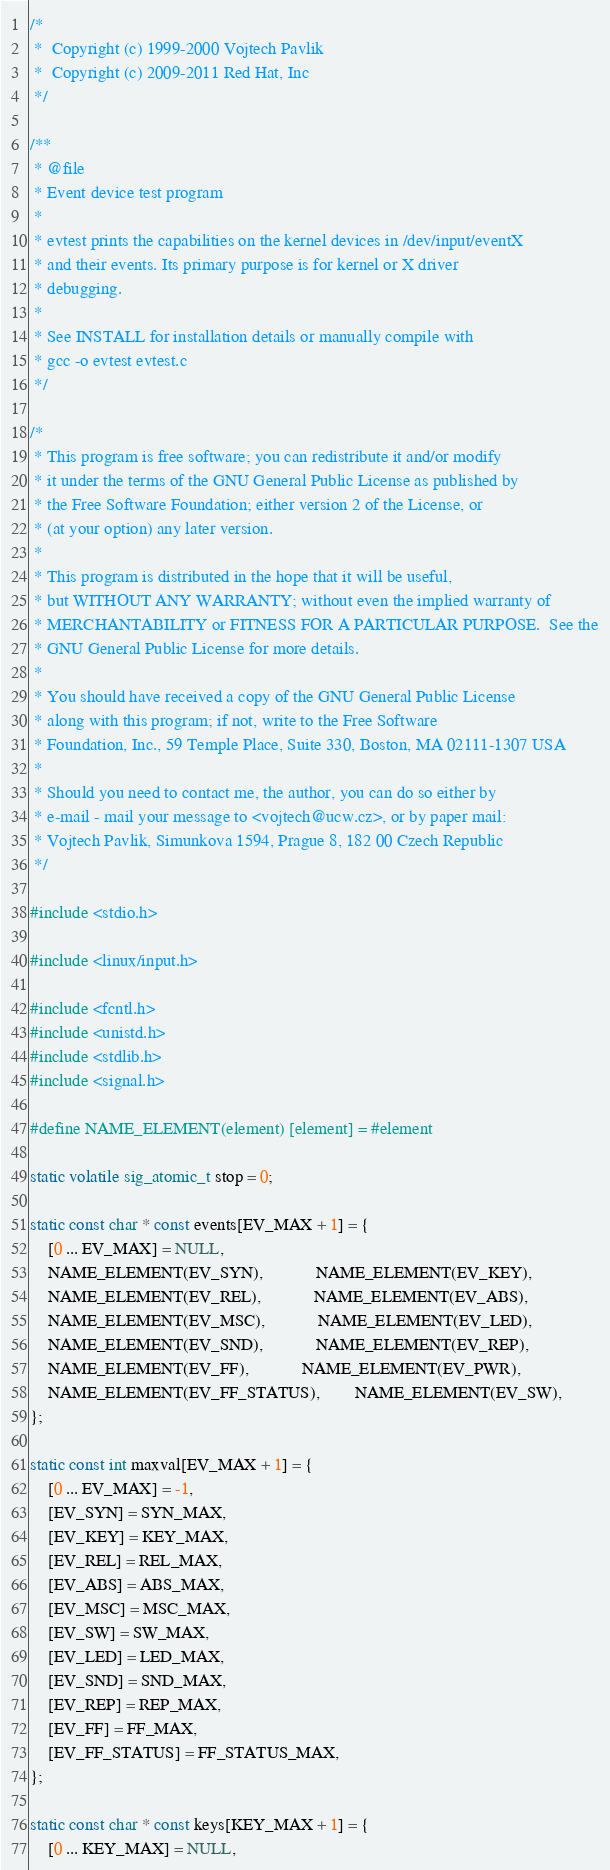<code> <loc_0><loc_0><loc_500><loc_500><_C_>/*
 *  Copyright (c) 1999-2000 Vojtech Pavlik
 *  Copyright (c) 2009-2011 Red Hat, Inc
 */

/**
 * @file
 * Event device test program
 *
 * evtest prints the capabilities on the kernel devices in /dev/input/eventX
 * and their events. Its primary purpose is for kernel or X driver
 * debugging.
 *
 * See INSTALL for installation details or manually compile with
 * gcc -o evtest evtest.c
 */

/*
 * This program is free software; you can redistribute it and/or modify
 * it under the terms of the GNU General Public License as published by
 * the Free Software Foundation; either version 2 of the License, or
 * (at your option) any later version.
 *
 * This program is distributed in the hope that it will be useful,
 * but WITHOUT ANY WARRANTY; without even the implied warranty of
 * MERCHANTABILITY or FITNESS FOR A PARTICULAR PURPOSE.  See the
 * GNU General Public License for more details.
 *
 * You should have received a copy of the GNU General Public License
 * along with this program; if not, write to the Free Software
 * Foundation, Inc., 59 Temple Place, Suite 330, Boston, MA 02111-1307 USA
 *
 * Should you need to contact me, the author, you can do so either by
 * e-mail - mail your message to <vojtech@ucw.cz>, or by paper mail:
 * Vojtech Pavlik, Simunkova 1594, Prague 8, 182 00 Czech Republic
 */

#include <stdio.h>

#include <linux/input.h>

#include <fcntl.h>
#include <unistd.h>
#include <stdlib.h>
#include <signal.h>

#define NAME_ELEMENT(element) [element] = #element

static volatile sig_atomic_t stop = 0;

static const char * const events[EV_MAX + 1] = {
	[0 ... EV_MAX] = NULL,
	NAME_ELEMENT(EV_SYN),			NAME_ELEMENT(EV_KEY),
	NAME_ELEMENT(EV_REL),			NAME_ELEMENT(EV_ABS),
	NAME_ELEMENT(EV_MSC),			NAME_ELEMENT(EV_LED),
	NAME_ELEMENT(EV_SND),			NAME_ELEMENT(EV_REP),
	NAME_ELEMENT(EV_FF),			NAME_ELEMENT(EV_PWR),
	NAME_ELEMENT(EV_FF_STATUS),		NAME_ELEMENT(EV_SW),
};

static const int maxval[EV_MAX + 1] = {
	[0 ... EV_MAX] = -1,
	[EV_SYN] = SYN_MAX,
	[EV_KEY] = KEY_MAX,
	[EV_REL] = REL_MAX,
	[EV_ABS] = ABS_MAX,
	[EV_MSC] = MSC_MAX,
	[EV_SW] = SW_MAX,
	[EV_LED] = LED_MAX,
	[EV_SND] = SND_MAX,
	[EV_REP] = REP_MAX,
	[EV_FF] = FF_MAX,
	[EV_FF_STATUS] = FF_STATUS_MAX,
};

static const char * const keys[KEY_MAX + 1] = {
	[0 ... KEY_MAX] = NULL,</code> 